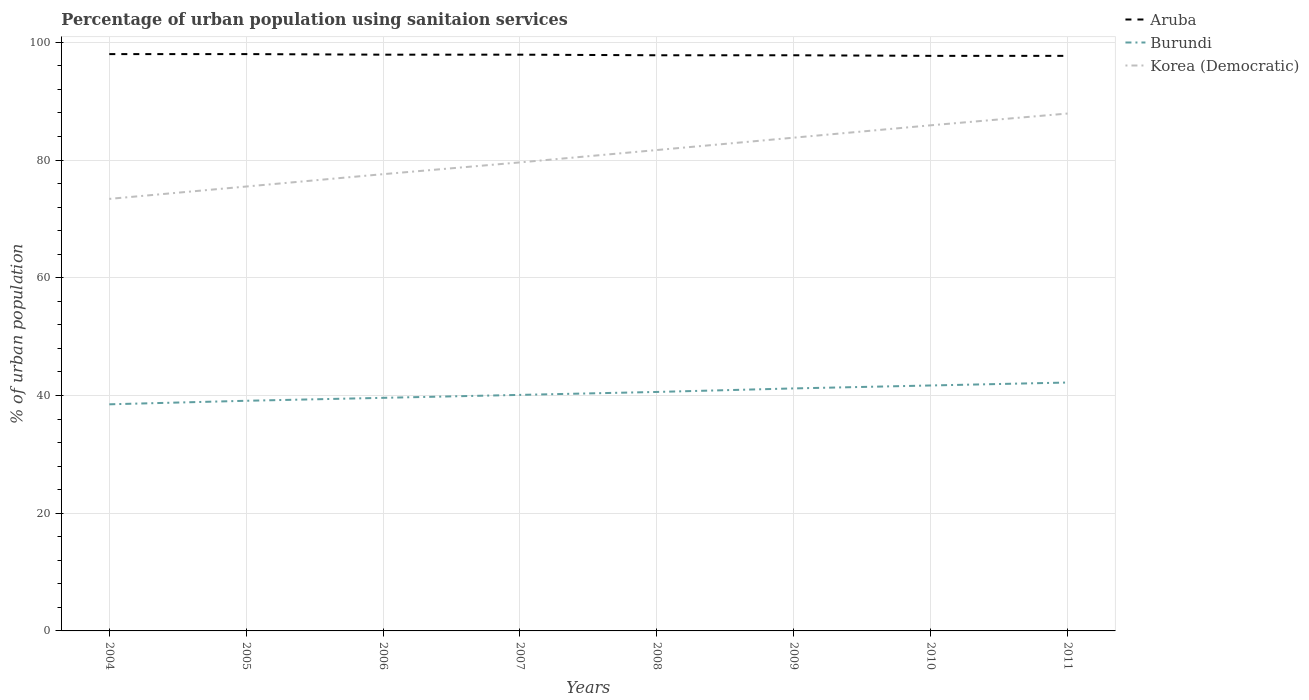How many different coloured lines are there?
Provide a short and direct response. 3. Does the line corresponding to Korea (Democratic) intersect with the line corresponding to Aruba?
Ensure brevity in your answer.  No. Across all years, what is the maximum percentage of urban population using sanitaion services in Korea (Democratic)?
Your answer should be compact. 73.4. What is the total percentage of urban population using sanitaion services in Burundi in the graph?
Your answer should be very brief. -0.5. What is the difference between the highest and the second highest percentage of urban population using sanitaion services in Burundi?
Provide a succinct answer. 3.7. Is the percentage of urban population using sanitaion services in Aruba strictly greater than the percentage of urban population using sanitaion services in Korea (Democratic) over the years?
Your answer should be compact. No. What is the difference between two consecutive major ticks on the Y-axis?
Make the answer very short. 20. Does the graph contain any zero values?
Offer a very short reply. No. Does the graph contain grids?
Keep it short and to the point. Yes. What is the title of the graph?
Your response must be concise. Percentage of urban population using sanitaion services. What is the label or title of the X-axis?
Offer a terse response. Years. What is the label or title of the Y-axis?
Your response must be concise. % of urban population. What is the % of urban population of Aruba in 2004?
Give a very brief answer. 98. What is the % of urban population in Burundi in 2004?
Your response must be concise. 38.5. What is the % of urban population of Korea (Democratic) in 2004?
Provide a succinct answer. 73.4. What is the % of urban population of Aruba in 2005?
Your response must be concise. 98. What is the % of urban population in Burundi in 2005?
Give a very brief answer. 39.1. What is the % of urban population of Korea (Democratic) in 2005?
Provide a short and direct response. 75.5. What is the % of urban population of Aruba in 2006?
Make the answer very short. 97.9. What is the % of urban population of Burundi in 2006?
Provide a short and direct response. 39.6. What is the % of urban population of Korea (Democratic) in 2006?
Make the answer very short. 77.6. What is the % of urban population in Aruba in 2007?
Your answer should be compact. 97.9. What is the % of urban population of Burundi in 2007?
Offer a very short reply. 40.1. What is the % of urban population in Korea (Democratic) in 2007?
Give a very brief answer. 79.6. What is the % of urban population in Aruba in 2008?
Offer a very short reply. 97.8. What is the % of urban population in Burundi in 2008?
Ensure brevity in your answer.  40.6. What is the % of urban population in Korea (Democratic) in 2008?
Offer a very short reply. 81.7. What is the % of urban population of Aruba in 2009?
Your answer should be very brief. 97.8. What is the % of urban population of Burundi in 2009?
Provide a succinct answer. 41.2. What is the % of urban population in Korea (Democratic) in 2009?
Provide a succinct answer. 83.8. What is the % of urban population in Aruba in 2010?
Ensure brevity in your answer.  97.7. What is the % of urban population in Burundi in 2010?
Make the answer very short. 41.7. What is the % of urban population of Korea (Democratic) in 2010?
Give a very brief answer. 85.9. What is the % of urban population of Aruba in 2011?
Ensure brevity in your answer.  97.7. What is the % of urban population of Burundi in 2011?
Give a very brief answer. 42.2. What is the % of urban population in Korea (Democratic) in 2011?
Offer a very short reply. 87.9. Across all years, what is the maximum % of urban population of Aruba?
Offer a very short reply. 98. Across all years, what is the maximum % of urban population of Burundi?
Give a very brief answer. 42.2. Across all years, what is the maximum % of urban population of Korea (Democratic)?
Keep it short and to the point. 87.9. Across all years, what is the minimum % of urban population in Aruba?
Give a very brief answer. 97.7. Across all years, what is the minimum % of urban population in Burundi?
Keep it short and to the point. 38.5. Across all years, what is the minimum % of urban population of Korea (Democratic)?
Offer a terse response. 73.4. What is the total % of urban population of Aruba in the graph?
Offer a very short reply. 782.8. What is the total % of urban population of Burundi in the graph?
Give a very brief answer. 323. What is the total % of urban population in Korea (Democratic) in the graph?
Ensure brevity in your answer.  645.4. What is the difference between the % of urban population of Aruba in 2004 and that in 2005?
Make the answer very short. 0. What is the difference between the % of urban population in Burundi in 2004 and that in 2005?
Your answer should be compact. -0.6. What is the difference between the % of urban population in Burundi in 2004 and that in 2007?
Make the answer very short. -1.6. What is the difference between the % of urban population of Korea (Democratic) in 2004 and that in 2007?
Your response must be concise. -6.2. What is the difference between the % of urban population in Aruba in 2004 and that in 2008?
Provide a succinct answer. 0.2. What is the difference between the % of urban population in Korea (Democratic) in 2004 and that in 2008?
Provide a succinct answer. -8.3. What is the difference between the % of urban population of Aruba in 2004 and that in 2009?
Provide a succinct answer. 0.2. What is the difference between the % of urban population of Korea (Democratic) in 2004 and that in 2009?
Your answer should be very brief. -10.4. What is the difference between the % of urban population of Aruba in 2004 and that in 2010?
Keep it short and to the point. 0.3. What is the difference between the % of urban population of Aruba in 2004 and that in 2011?
Give a very brief answer. 0.3. What is the difference between the % of urban population of Korea (Democratic) in 2004 and that in 2011?
Your answer should be compact. -14.5. What is the difference between the % of urban population of Aruba in 2005 and that in 2006?
Provide a succinct answer. 0.1. What is the difference between the % of urban population of Korea (Democratic) in 2005 and that in 2006?
Offer a very short reply. -2.1. What is the difference between the % of urban population in Burundi in 2005 and that in 2007?
Give a very brief answer. -1. What is the difference between the % of urban population in Korea (Democratic) in 2005 and that in 2007?
Give a very brief answer. -4.1. What is the difference between the % of urban population in Burundi in 2005 and that in 2008?
Your answer should be very brief. -1.5. What is the difference between the % of urban population in Korea (Democratic) in 2005 and that in 2008?
Give a very brief answer. -6.2. What is the difference between the % of urban population of Korea (Democratic) in 2005 and that in 2009?
Give a very brief answer. -8.3. What is the difference between the % of urban population of Korea (Democratic) in 2005 and that in 2010?
Provide a short and direct response. -10.4. What is the difference between the % of urban population in Aruba in 2005 and that in 2011?
Make the answer very short. 0.3. What is the difference between the % of urban population of Korea (Democratic) in 2005 and that in 2011?
Provide a succinct answer. -12.4. What is the difference between the % of urban population of Aruba in 2006 and that in 2007?
Keep it short and to the point. 0. What is the difference between the % of urban population in Burundi in 2006 and that in 2007?
Provide a short and direct response. -0.5. What is the difference between the % of urban population of Korea (Democratic) in 2006 and that in 2007?
Provide a short and direct response. -2. What is the difference between the % of urban population in Aruba in 2006 and that in 2008?
Your response must be concise. 0.1. What is the difference between the % of urban population of Burundi in 2006 and that in 2008?
Keep it short and to the point. -1. What is the difference between the % of urban population of Korea (Democratic) in 2006 and that in 2008?
Your response must be concise. -4.1. What is the difference between the % of urban population of Aruba in 2006 and that in 2009?
Provide a succinct answer. 0.1. What is the difference between the % of urban population in Aruba in 2006 and that in 2010?
Your response must be concise. 0.2. What is the difference between the % of urban population in Aruba in 2006 and that in 2011?
Keep it short and to the point. 0.2. What is the difference between the % of urban population in Burundi in 2006 and that in 2011?
Provide a short and direct response. -2.6. What is the difference between the % of urban population of Aruba in 2007 and that in 2008?
Your answer should be compact. 0.1. What is the difference between the % of urban population in Burundi in 2007 and that in 2008?
Provide a short and direct response. -0.5. What is the difference between the % of urban population of Aruba in 2007 and that in 2009?
Keep it short and to the point. 0.1. What is the difference between the % of urban population of Burundi in 2007 and that in 2009?
Ensure brevity in your answer.  -1.1. What is the difference between the % of urban population in Aruba in 2007 and that in 2010?
Offer a terse response. 0.2. What is the difference between the % of urban population of Aruba in 2007 and that in 2011?
Provide a succinct answer. 0.2. What is the difference between the % of urban population of Korea (Democratic) in 2007 and that in 2011?
Your answer should be very brief. -8.3. What is the difference between the % of urban population in Korea (Democratic) in 2008 and that in 2009?
Your response must be concise. -2.1. What is the difference between the % of urban population of Aruba in 2008 and that in 2010?
Your response must be concise. 0.1. What is the difference between the % of urban population in Korea (Democratic) in 2008 and that in 2010?
Your answer should be very brief. -4.2. What is the difference between the % of urban population in Burundi in 2008 and that in 2011?
Your response must be concise. -1.6. What is the difference between the % of urban population in Aruba in 2009 and that in 2010?
Your response must be concise. 0.1. What is the difference between the % of urban population of Burundi in 2009 and that in 2010?
Provide a succinct answer. -0.5. What is the difference between the % of urban population of Korea (Democratic) in 2009 and that in 2010?
Offer a terse response. -2.1. What is the difference between the % of urban population in Korea (Democratic) in 2009 and that in 2011?
Provide a succinct answer. -4.1. What is the difference between the % of urban population in Aruba in 2010 and that in 2011?
Your answer should be very brief. 0. What is the difference between the % of urban population in Korea (Democratic) in 2010 and that in 2011?
Provide a short and direct response. -2. What is the difference between the % of urban population in Aruba in 2004 and the % of urban population in Burundi in 2005?
Offer a very short reply. 58.9. What is the difference between the % of urban population of Aruba in 2004 and the % of urban population of Korea (Democratic) in 2005?
Offer a very short reply. 22.5. What is the difference between the % of urban population in Burundi in 2004 and the % of urban population in Korea (Democratic) in 2005?
Provide a short and direct response. -37. What is the difference between the % of urban population of Aruba in 2004 and the % of urban population of Burundi in 2006?
Offer a very short reply. 58.4. What is the difference between the % of urban population of Aruba in 2004 and the % of urban population of Korea (Democratic) in 2006?
Make the answer very short. 20.4. What is the difference between the % of urban population of Burundi in 2004 and the % of urban population of Korea (Democratic) in 2006?
Ensure brevity in your answer.  -39.1. What is the difference between the % of urban population of Aruba in 2004 and the % of urban population of Burundi in 2007?
Keep it short and to the point. 57.9. What is the difference between the % of urban population in Aruba in 2004 and the % of urban population in Korea (Democratic) in 2007?
Give a very brief answer. 18.4. What is the difference between the % of urban population in Burundi in 2004 and the % of urban population in Korea (Democratic) in 2007?
Ensure brevity in your answer.  -41.1. What is the difference between the % of urban population of Aruba in 2004 and the % of urban population of Burundi in 2008?
Your response must be concise. 57.4. What is the difference between the % of urban population in Aruba in 2004 and the % of urban population in Korea (Democratic) in 2008?
Offer a terse response. 16.3. What is the difference between the % of urban population of Burundi in 2004 and the % of urban population of Korea (Democratic) in 2008?
Provide a short and direct response. -43.2. What is the difference between the % of urban population of Aruba in 2004 and the % of urban population of Burundi in 2009?
Offer a terse response. 56.8. What is the difference between the % of urban population in Aruba in 2004 and the % of urban population in Korea (Democratic) in 2009?
Your answer should be compact. 14.2. What is the difference between the % of urban population in Burundi in 2004 and the % of urban population in Korea (Democratic) in 2009?
Your response must be concise. -45.3. What is the difference between the % of urban population in Aruba in 2004 and the % of urban population in Burundi in 2010?
Provide a succinct answer. 56.3. What is the difference between the % of urban population of Aruba in 2004 and the % of urban population of Korea (Democratic) in 2010?
Offer a terse response. 12.1. What is the difference between the % of urban population in Burundi in 2004 and the % of urban population in Korea (Democratic) in 2010?
Keep it short and to the point. -47.4. What is the difference between the % of urban population of Aruba in 2004 and the % of urban population of Burundi in 2011?
Your answer should be very brief. 55.8. What is the difference between the % of urban population in Burundi in 2004 and the % of urban population in Korea (Democratic) in 2011?
Ensure brevity in your answer.  -49.4. What is the difference between the % of urban population of Aruba in 2005 and the % of urban population of Burundi in 2006?
Give a very brief answer. 58.4. What is the difference between the % of urban population in Aruba in 2005 and the % of urban population in Korea (Democratic) in 2006?
Provide a succinct answer. 20.4. What is the difference between the % of urban population of Burundi in 2005 and the % of urban population of Korea (Democratic) in 2006?
Ensure brevity in your answer.  -38.5. What is the difference between the % of urban population in Aruba in 2005 and the % of urban population in Burundi in 2007?
Your answer should be very brief. 57.9. What is the difference between the % of urban population in Aruba in 2005 and the % of urban population in Korea (Democratic) in 2007?
Keep it short and to the point. 18.4. What is the difference between the % of urban population in Burundi in 2005 and the % of urban population in Korea (Democratic) in 2007?
Offer a terse response. -40.5. What is the difference between the % of urban population in Aruba in 2005 and the % of urban population in Burundi in 2008?
Your answer should be very brief. 57.4. What is the difference between the % of urban population in Burundi in 2005 and the % of urban population in Korea (Democratic) in 2008?
Offer a very short reply. -42.6. What is the difference between the % of urban population in Aruba in 2005 and the % of urban population in Burundi in 2009?
Your answer should be very brief. 56.8. What is the difference between the % of urban population in Aruba in 2005 and the % of urban population in Korea (Democratic) in 2009?
Make the answer very short. 14.2. What is the difference between the % of urban population in Burundi in 2005 and the % of urban population in Korea (Democratic) in 2009?
Make the answer very short. -44.7. What is the difference between the % of urban population of Aruba in 2005 and the % of urban population of Burundi in 2010?
Ensure brevity in your answer.  56.3. What is the difference between the % of urban population in Burundi in 2005 and the % of urban population in Korea (Democratic) in 2010?
Ensure brevity in your answer.  -46.8. What is the difference between the % of urban population in Aruba in 2005 and the % of urban population in Burundi in 2011?
Keep it short and to the point. 55.8. What is the difference between the % of urban population in Burundi in 2005 and the % of urban population in Korea (Democratic) in 2011?
Your answer should be compact. -48.8. What is the difference between the % of urban population of Aruba in 2006 and the % of urban population of Burundi in 2007?
Ensure brevity in your answer.  57.8. What is the difference between the % of urban population of Aruba in 2006 and the % of urban population of Korea (Democratic) in 2007?
Your answer should be very brief. 18.3. What is the difference between the % of urban population of Burundi in 2006 and the % of urban population of Korea (Democratic) in 2007?
Provide a short and direct response. -40. What is the difference between the % of urban population in Aruba in 2006 and the % of urban population in Burundi in 2008?
Your response must be concise. 57.3. What is the difference between the % of urban population in Aruba in 2006 and the % of urban population in Korea (Democratic) in 2008?
Offer a very short reply. 16.2. What is the difference between the % of urban population of Burundi in 2006 and the % of urban population of Korea (Democratic) in 2008?
Provide a succinct answer. -42.1. What is the difference between the % of urban population of Aruba in 2006 and the % of urban population of Burundi in 2009?
Your answer should be very brief. 56.7. What is the difference between the % of urban population of Aruba in 2006 and the % of urban population of Korea (Democratic) in 2009?
Your answer should be compact. 14.1. What is the difference between the % of urban population in Burundi in 2006 and the % of urban population in Korea (Democratic) in 2009?
Offer a very short reply. -44.2. What is the difference between the % of urban population in Aruba in 2006 and the % of urban population in Burundi in 2010?
Offer a terse response. 56.2. What is the difference between the % of urban population of Aruba in 2006 and the % of urban population of Korea (Democratic) in 2010?
Your answer should be very brief. 12. What is the difference between the % of urban population of Burundi in 2006 and the % of urban population of Korea (Democratic) in 2010?
Provide a succinct answer. -46.3. What is the difference between the % of urban population in Aruba in 2006 and the % of urban population in Burundi in 2011?
Provide a succinct answer. 55.7. What is the difference between the % of urban population of Burundi in 2006 and the % of urban population of Korea (Democratic) in 2011?
Your response must be concise. -48.3. What is the difference between the % of urban population in Aruba in 2007 and the % of urban population in Burundi in 2008?
Your answer should be very brief. 57.3. What is the difference between the % of urban population of Burundi in 2007 and the % of urban population of Korea (Democratic) in 2008?
Offer a terse response. -41.6. What is the difference between the % of urban population in Aruba in 2007 and the % of urban population in Burundi in 2009?
Provide a short and direct response. 56.7. What is the difference between the % of urban population of Burundi in 2007 and the % of urban population of Korea (Democratic) in 2009?
Your answer should be compact. -43.7. What is the difference between the % of urban population in Aruba in 2007 and the % of urban population in Burundi in 2010?
Give a very brief answer. 56.2. What is the difference between the % of urban population in Aruba in 2007 and the % of urban population in Korea (Democratic) in 2010?
Your answer should be very brief. 12. What is the difference between the % of urban population in Burundi in 2007 and the % of urban population in Korea (Democratic) in 2010?
Ensure brevity in your answer.  -45.8. What is the difference between the % of urban population in Aruba in 2007 and the % of urban population in Burundi in 2011?
Your response must be concise. 55.7. What is the difference between the % of urban population in Burundi in 2007 and the % of urban population in Korea (Democratic) in 2011?
Your answer should be very brief. -47.8. What is the difference between the % of urban population in Aruba in 2008 and the % of urban population in Burundi in 2009?
Provide a short and direct response. 56.6. What is the difference between the % of urban population in Burundi in 2008 and the % of urban population in Korea (Democratic) in 2009?
Give a very brief answer. -43.2. What is the difference between the % of urban population of Aruba in 2008 and the % of urban population of Burundi in 2010?
Your answer should be compact. 56.1. What is the difference between the % of urban population of Burundi in 2008 and the % of urban population of Korea (Democratic) in 2010?
Provide a succinct answer. -45.3. What is the difference between the % of urban population in Aruba in 2008 and the % of urban population in Burundi in 2011?
Ensure brevity in your answer.  55.6. What is the difference between the % of urban population in Aruba in 2008 and the % of urban population in Korea (Democratic) in 2011?
Your answer should be very brief. 9.9. What is the difference between the % of urban population of Burundi in 2008 and the % of urban population of Korea (Democratic) in 2011?
Ensure brevity in your answer.  -47.3. What is the difference between the % of urban population of Aruba in 2009 and the % of urban population of Burundi in 2010?
Provide a succinct answer. 56.1. What is the difference between the % of urban population of Burundi in 2009 and the % of urban population of Korea (Democratic) in 2010?
Offer a very short reply. -44.7. What is the difference between the % of urban population in Aruba in 2009 and the % of urban population in Burundi in 2011?
Make the answer very short. 55.6. What is the difference between the % of urban population in Burundi in 2009 and the % of urban population in Korea (Democratic) in 2011?
Offer a very short reply. -46.7. What is the difference between the % of urban population in Aruba in 2010 and the % of urban population in Burundi in 2011?
Your answer should be very brief. 55.5. What is the difference between the % of urban population in Aruba in 2010 and the % of urban population in Korea (Democratic) in 2011?
Your answer should be compact. 9.8. What is the difference between the % of urban population of Burundi in 2010 and the % of urban population of Korea (Democratic) in 2011?
Keep it short and to the point. -46.2. What is the average % of urban population in Aruba per year?
Make the answer very short. 97.85. What is the average % of urban population in Burundi per year?
Offer a very short reply. 40.38. What is the average % of urban population in Korea (Democratic) per year?
Give a very brief answer. 80.67. In the year 2004, what is the difference between the % of urban population of Aruba and % of urban population of Burundi?
Your response must be concise. 59.5. In the year 2004, what is the difference between the % of urban population of Aruba and % of urban population of Korea (Democratic)?
Your response must be concise. 24.6. In the year 2004, what is the difference between the % of urban population of Burundi and % of urban population of Korea (Democratic)?
Your response must be concise. -34.9. In the year 2005, what is the difference between the % of urban population of Aruba and % of urban population of Burundi?
Your answer should be compact. 58.9. In the year 2005, what is the difference between the % of urban population in Aruba and % of urban population in Korea (Democratic)?
Keep it short and to the point. 22.5. In the year 2005, what is the difference between the % of urban population in Burundi and % of urban population in Korea (Democratic)?
Make the answer very short. -36.4. In the year 2006, what is the difference between the % of urban population of Aruba and % of urban population of Burundi?
Provide a succinct answer. 58.3. In the year 2006, what is the difference between the % of urban population in Aruba and % of urban population in Korea (Democratic)?
Make the answer very short. 20.3. In the year 2006, what is the difference between the % of urban population in Burundi and % of urban population in Korea (Democratic)?
Provide a short and direct response. -38. In the year 2007, what is the difference between the % of urban population in Aruba and % of urban population in Burundi?
Give a very brief answer. 57.8. In the year 2007, what is the difference between the % of urban population of Burundi and % of urban population of Korea (Democratic)?
Provide a short and direct response. -39.5. In the year 2008, what is the difference between the % of urban population of Aruba and % of urban population of Burundi?
Your answer should be very brief. 57.2. In the year 2008, what is the difference between the % of urban population of Aruba and % of urban population of Korea (Democratic)?
Provide a succinct answer. 16.1. In the year 2008, what is the difference between the % of urban population of Burundi and % of urban population of Korea (Democratic)?
Offer a very short reply. -41.1. In the year 2009, what is the difference between the % of urban population of Aruba and % of urban population of Burundi?
Your answer should be very brief. 56.6. In the year 2009, what is the difference between the % of urban population in Aruba and % of urban population in Korea (Democratic)?
Keep it short and to the point. 14. In the year 2009, what is the difference between the % of urban population of Burundi and % of urban population of Korea (Democratic)?
Provide a succinct answer. -42.6. In the year 2010, what is the difference between the % of urban population in Aruba and % of urban population in Burundi?
Give a very brief answer. 56. In the year 2010, what is the difference between the % of urban population of Burundi and % of urban population of Korea (Democratic)?
Ensure brevity in your answer.  -44.2. In the year 2011, what is the difference between the % of urban population in Aruba and % of urban population in Burundi?
Provide a short and direct response. 55.5. In the year 2011, what is the difference between the % of urban population of Aruba and % of urban population of Korea (Democratic)?
Your answer should be very brief. 9.8. In the year 2011, what is the difference between the % of urban population of Burundi and % of urban population of Korea (Democratic)?
Your answer should be compact. -45.7. What is the ratio of the % of urban population in Aruba in 2004 to that in 2005?
Provide a succinct answer. 1. What is the ratio of the % of urban population in Burundi in 2004 to that in 2005?
Provide a short and direct response. 0.98. What is the ratio of the % of urban population in Korea (Democratic) in 2004 to that in 2005?
Make the answer very short. 0.97. What is the ratio of the % of urban population in Burundi in 2004 to that in 2006?
Your answer should be compact. 0.97. What is the ratio of the % of urban population in Korea (Democratic) in 2004 to that in 2006?
Your answer should be compact. 0.95. What is the ratio of the % of urban population of Aruba in 2004 to that in 2007?
Your response must be concise. 1. What is the ratio of the % of urban population in Burundi in 2004 to that in 2007?
Your response must be concise. 0.96. What is the ratio of the % of urban population in Korea (Democratic) in 2004 to that in 2007?
Give a very brief answer. 0.92. What is the ratio of the % of urban population of Burundi in 2004 to that in 2008?
Offer a very short reply. 0.95. What is the ratio of the % of urban population of Korea (Democratic) in 2004 to that in 2008?
Keep it short and to the point. 0.9. What is the ratio of the % of urban population in Burundi in 2004 to that in 2009?
Offer a terse response. 0.93. What is the ratio of the % of urban population in Korea (Democratic) in 2004 to that in 2009?
Provide a short and direct response. 0.88. What is the ratio of the % of urban population of Burundi in 2004 to that in 2010?
Make the answer very short. 0.92. What is the ratio of the % of urban population of Korea (Democratic) in 2004 to that in 2010?
Ensure brevity in your answer.  0.85. What is the ratio of the % of urban population of Burundi in 2004 to that in 2011?
Offer a very short reply. 0.91. What is the ratio of the % of urban population in Korea (Democratic) in 2004 to that in 2011?
Keep it short and to the point. 0.83. What is the ratio of the % of urban population in Aruba in 2005 to that in 2006?
Ensure brevity in your answer.  1. What is the ratio of the % of urban population of Burundi in 2005 to that in 2006?
Offer a very short reply. 0.99. What is the ratio of the % of urban population in Korea (Democratic) in 2005 to that in 2006?
Your answer should be compact. 0.97. What is the ratio of the % of urban population in Burundi in 2005 to that in 2007?
Your answer should be compact. 0.98. What is the ratio of the % of urban population of Korea (Democratic) in 2005 to that in 2007?
Provide a short and direct response. 0.95. What is the ratio of the % of urban population in Burundi in 2005 to that in 2008?
Make the answer very short. 0.96. What is the ratio of the % of urban population in Korea (Democratic) in 2005 to that in 2008?
Offer a very short reply. 0.92. What is the ratio of the % of urban population of Burundi in 2005 to that in 2009?
Your answer should be very brief. 0.95. What is the ratio of the % of urban population of Korea (Democratic) in 2005 to that in 2009?
Provide a succinct answer. 0.9. What is the ratio of the % of urban population of Burundi in 2005 to that in 2010?
Provide a succinct answer. 0.94. What is the ratio of the % of urban population in Korea (Democratic) in 2005 to that in 2010?
Ensure brevity in your answer.  0.88. What is the ratio of the % of urban population of Burundi in 2005 to that in 2011?
Your answer should be compact. 0.93. What is the ratio of the % of urban population in Korea (Democratic) in 2005 to that in 2011?
Provide a short and direct response. 0.86. What is the ratio of the % of urban population of Aruba in 2006 to that in 2007?
Offer a very short reply. 1. What is the ratio of the % of urban population of Burundi in 2006 to that in 2007?
Ensure brevity in your answer.  0.99. What is the ratio of the % of urban population in Korea (Democratic) in 2006 to that in 2007?
Your answer should be compact. 0.97. What is the ratio of the % of urban population in Burundi in 2006 to that in 2008?
Provide a short and direct response. 0.98. What is the ratio of the % of urban population in Korea (Democratic) in 2006 to that in 2008?
Your answer should be compact. 0.95. What is the ratio of the % of urban population in Burundi in 2006 to that in 2009?
Make the answer very short. 0.96. What is the ratio of the % of urban population in Korea (Democratic) in 2006 to that in 2009?
Offer a very short reply. 0.93. What is the ratio of the % of urban population in Burundi in 2006 to that in 2010?
Make the answer very short. 0.95. What is the ratio of the % of urban population in Korea (Democratic) in 2006 to that in 2010?
Keep it short and to the point. 0.9. What is the ratio of the % of urban population of Aruba in 2006 to that in 2011?
Keep it short and to the point. 1. What is the ratio of the % of urban population of Burundi in 2006 to that in 2011?
Offer a terse response. 0.94. What is the ratio of the % of urban population of Korea (Democratic) in 2006 to that in 2011?
Keep it short and to the point. 0.88. What is the ratio of the % of urban population in Aruba in 2007 to that in 2008?
Provide a short and direct response. 1. What is the ratio of the % of urban population of Burundi in 2007 to that in 2008?
Provide a succinct answer. 0.99. What is the ratio of the % of urban population in Korea (Democratic) in 2007 to that in 2008?
Offer a very short reply. 0.97. What is the ratio of the % of urban population of Aruba in 2007 to that in 2009?
Your response must be concise. 1. What is the ratio of the % of urban population in Burundi in 2007 to that in 2009?
Your response must be concise. 0.97. What is the ratio of the % of urban population of Korea (Democratic) in 2007 to that in 2009?
Offer a very short reply. 0.95. What is the ratio of the % of urban population in Aruba in 2007 to that in 2010?
Your answer should be compact. 1. What is the ratio of the % of urban population in Burundi in 2007 to that in 2010?
Provide a succinct answer. 0.96. What is the ratio of the % of urban population of Korea (Democratic) in 2007 to that in 2010?
Offer a very short reply. 0.93. What is the ratio of the % of urban population of Burundi in 2007 to that in 2011?
Ensure brevity in your answer.  0.95. What is the ratio of the % of urban population of Korea (Democratic) in 2007 to that in 2011?
Provide a succinct answer. 0.91. What is the ratio of the % of urban population of Burundi in 2008 to that in 2009?
Offer a very short reply. 0.99. What is the ratio of the % of urban population of Korea (Democratic) in 2008 to that in 2009?
Provide a short and direct response. 0.97. What is the ratio of the % of urban population of Burundi in 2008 to that in 2010?
Keep it short and to the point. 0.97. What is the ratio of the % of urban population in Korea (Democratic) in 2008 to that in 2010?
Offer a very short reply. 0.95. What is the ratio of the % of urban population in Aruba in 2008 to that in 2011?
Your answer should be very brief. 1. What is the ratio of the % of urban population of Burundi in 2008 to that in 2011?
Offer a terse response. 0.96. What is the ratio of the % of urban population in Korea (Democratic) in 2008 to that in 2011?
Your answer should be compact. 0.93. What is the ratio of the % of urban population in Burundi in 2009 to that in 2010?
Keep it short and to the point. 0.99. What is the ratio of the % of urban population in Korea (Democratic) in 2009 to that in 2010?
Offer a very short reply. 0.98. What is the ratio of the % of urban population of Aruba in 2009 to that in 2011?
Offer a terse response. 1. What is the ratio of the % of urban population of Burundi in 2009 to that in 2011?
Your answer should be compact. 0.98. What is the ratio of the % of urban population of Korea (Democratic) in 2009 to that in 2011?
Provide a short and direct response. 0.95. What is the ratio of the % of urban population of Aruba in 2010 to that in 2011?
Your answer should be very brief. 1. What is the ratio of the % of urban population in Burundi in 2010 to that in 2011?
Provide a succinct answer. 0.99. What is the ratio of the % of urban population of Korea (Democratic) in 2010 to that in 2011?
Offer a very short reply. 0.98. What is the difference between the highest and the second highest % of urban population of Aruba?
Offer a very short reply. 0. What is the difference between the highest and the second highest % of urban population in Burundi?
Your answer should be very brief. 0.5. What is the difference between the highest and the lowest % of urban population of Aruba?
Your answer should be very brief. 0.3. 